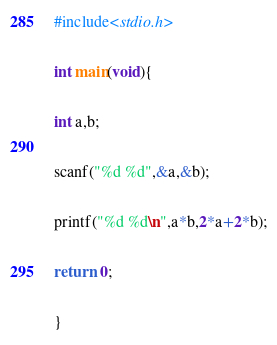<code> <loc_0><loc_0><loc_500><loc_500><_C_>#include<stdio.h>

int main(void){

int a,b;

scanf("%d %d",&a,&b);

printf("%d %d\n",a*b,2*a+2*b);

return  0;

}</code> 